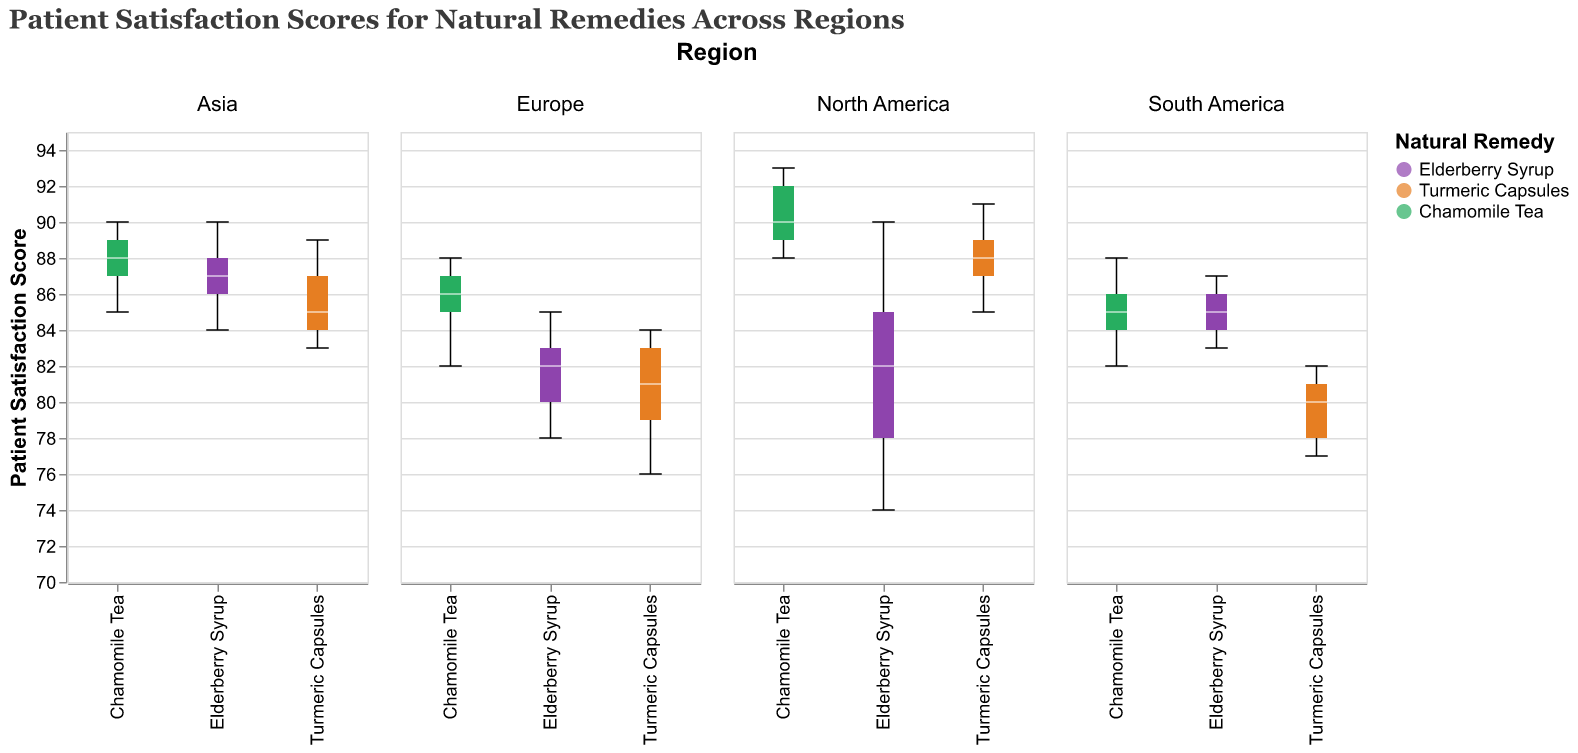What is the title of the figure? The title of the figure is displayed at the top and reads, "Patient Satisfaction Scores for Natural Remedies Across Regions".
Answer: Patient Satisfaction Scores for Natural Remedies Across Regions What natural remedies are included in the analysis? The plot legend shows the three natural remedies as Elderberry Syrup, Turmeric Capsules, and Chamomile Tea.
Answer: Elderberry Syrup, Turmeric Capsules, Chamomile Tea Which region has the highest median satisfaction for Chamomile Tea? The middle line (median) of the box plot for Chamomile Tea in North America is the highest compared to the median lines for Chamomile Tea in other regions.
Answer: North America In which region do Turmeric Capsules show the lowest minimum patient satisfaction scores? By looking at the bottom whiskers of the box plots, South America's Turmeric Capsules have the lowest end, indicating the lowest minimum satisfaction score.
Answer: South America What is the approximate range of patient satisfaction scores for Elderberry Syrup in Europe? The whiskers of the Elderberry Syrup box plot in Europe extend from around 78 to 85.
Answer: 78-85 Which natural remedy has the highest maximum satisfaction score in any region? Chamomile Tea in North America has the uppermost whisker reaching approximately 93, which is the highest satisfaction score recorded in any region.
Answer: Chamomile Tea Compare the median satisfaction scores of Elderberry Syrup between Asia and Europe. What do you observe? The median line of the Elderberry Syrup box plot in Asia is higher compared to the median line in Europe. This indicates that Asia has a higher median satisfaction score for Elderberry Syrup than Europe.
Answer: Asia is higher How does the spread of scores for Turmeric Capsules in North America compare to that in Europe? The interquartile range (distance between the top and bottom of the boxes) of Turmeric Capsules in North America is narrower than in Europe, indicating a smaller spread in satisfaction scores.
Answer: Smaller spread in North America Which region shows the least variability in patient satisfaction scores for Chamomile Tea? The box plot for Chamomile Tea in Europe is the narrowest, indicating the least variability in patient satisfaction scores.
Answer: Europe What can we infer about the consistency of patient satisfaction for Turmeric Capsules in Asia compared to other regions? Observing the size of the box and the length of the whiskers, Turmeric Capsules in Asia have a relatively narrow interquartile range and short whiskers, indicating consistent satisfaction scores compared to other regions.
Answer: More consistent 